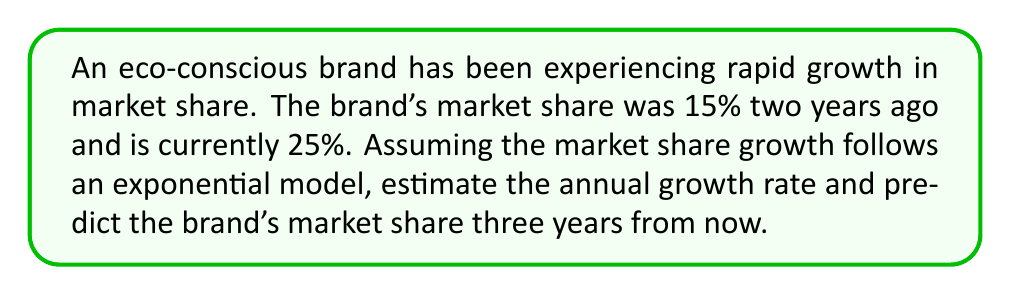Show me your answer to this math problem. To solve this problem, we'll use the exponential growth model:

$$A = P(1 + r)^t$$

Where:
$A$ = Final amount (current market share)
$P$ = Initial amount (market share two years ago)
$r$ = Annual growth rate (what we need to find)
$t$ = Time period (2 years in this case)

Step 1: Set up the equation using the given information:
$$25 = 15(1 + r)^2$$

Step 2: Divide both sides by 15:
$$\frac{25}{15} = (1 + r)^2$$

Step 3: Take the square root of both sides:
$$\sqrt{\frac{25}{15}} = 1 + r$$

Step 4: Subtract 1 from both sides to isolate r:
$$\sqrt{\frac{25}{15}} - 1 = r$$

Step 5: Calculate the value of r:
$$r \approx 0.2910 \text{ or } 29.10\%$$

Now that we have the annual growth rate, we can predict the market share three years from now:

Step 6: Use the exponential growth model again, with the current market share as the initial amount and t = 3 years:

$$A = 25(1 + 0.2910)^3$$

Step 7: Calculate the future market share:
$$A \approx 53.73\%$$
Answer: The estimated annual growth rate is approximately 29.10%, and the predicted market share three years from now is approximately 53.73%. 